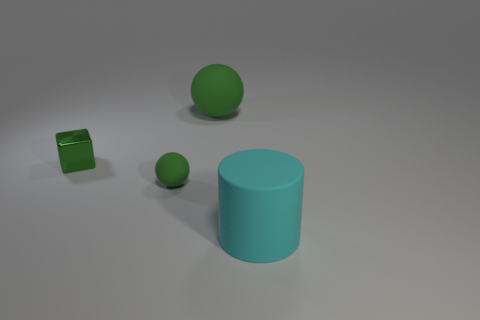How would you describe the overall composition of the objects in the image? The composition presents a simple and uncluttered arrangement with ample negative space. There are three objects which stand out due to their solid colors and distinct geometrical shapes: a large cyan cylinder, a small green sphere, and a small green cube. The objects are placed on a flat surface with a matte finish, giving the scene a calm and balanced aesthetic. 